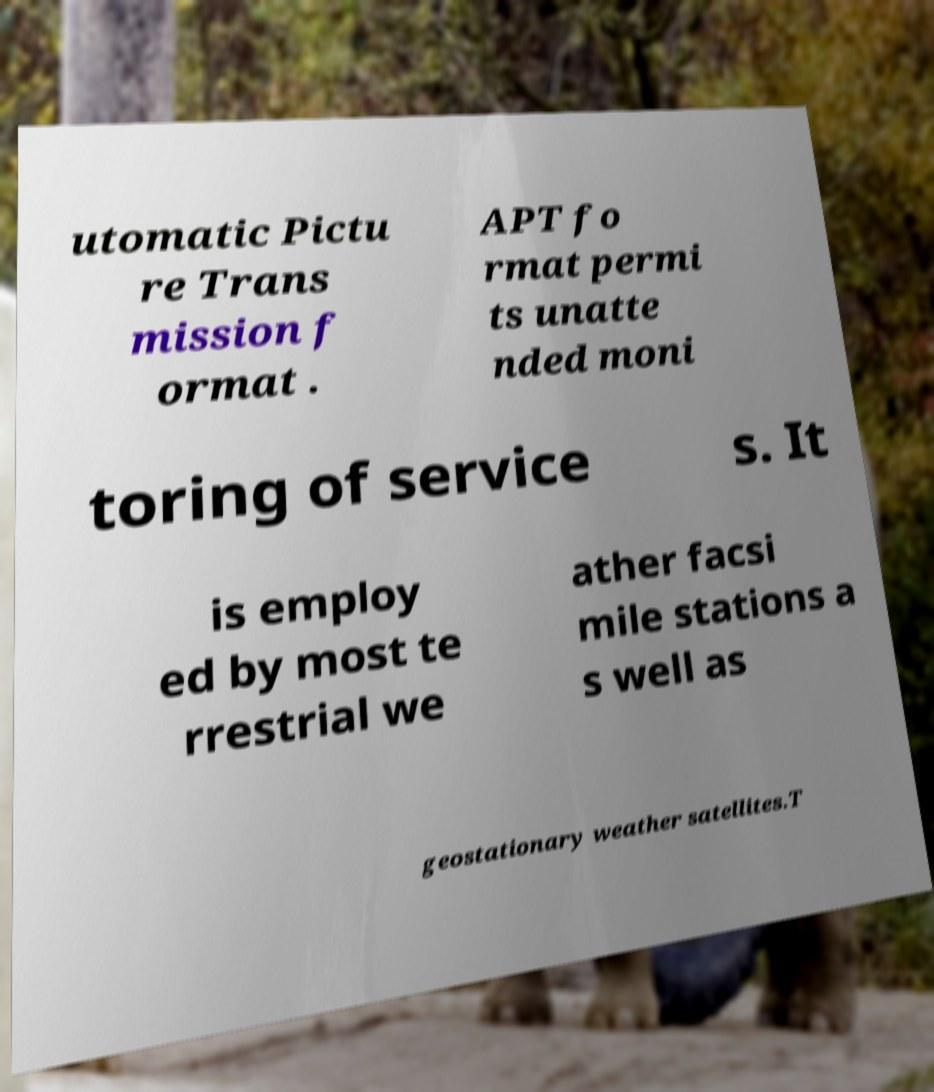Can you accurately transcribe the text from the provided image for me? utomatic Pictu re Trans mission f ormat . APT fo rmat permi ts unatte nded moni toring of service s. It is employ ed by most te rrestrial we ather facsi mile stations a s well as geostationary weather satellites.T 